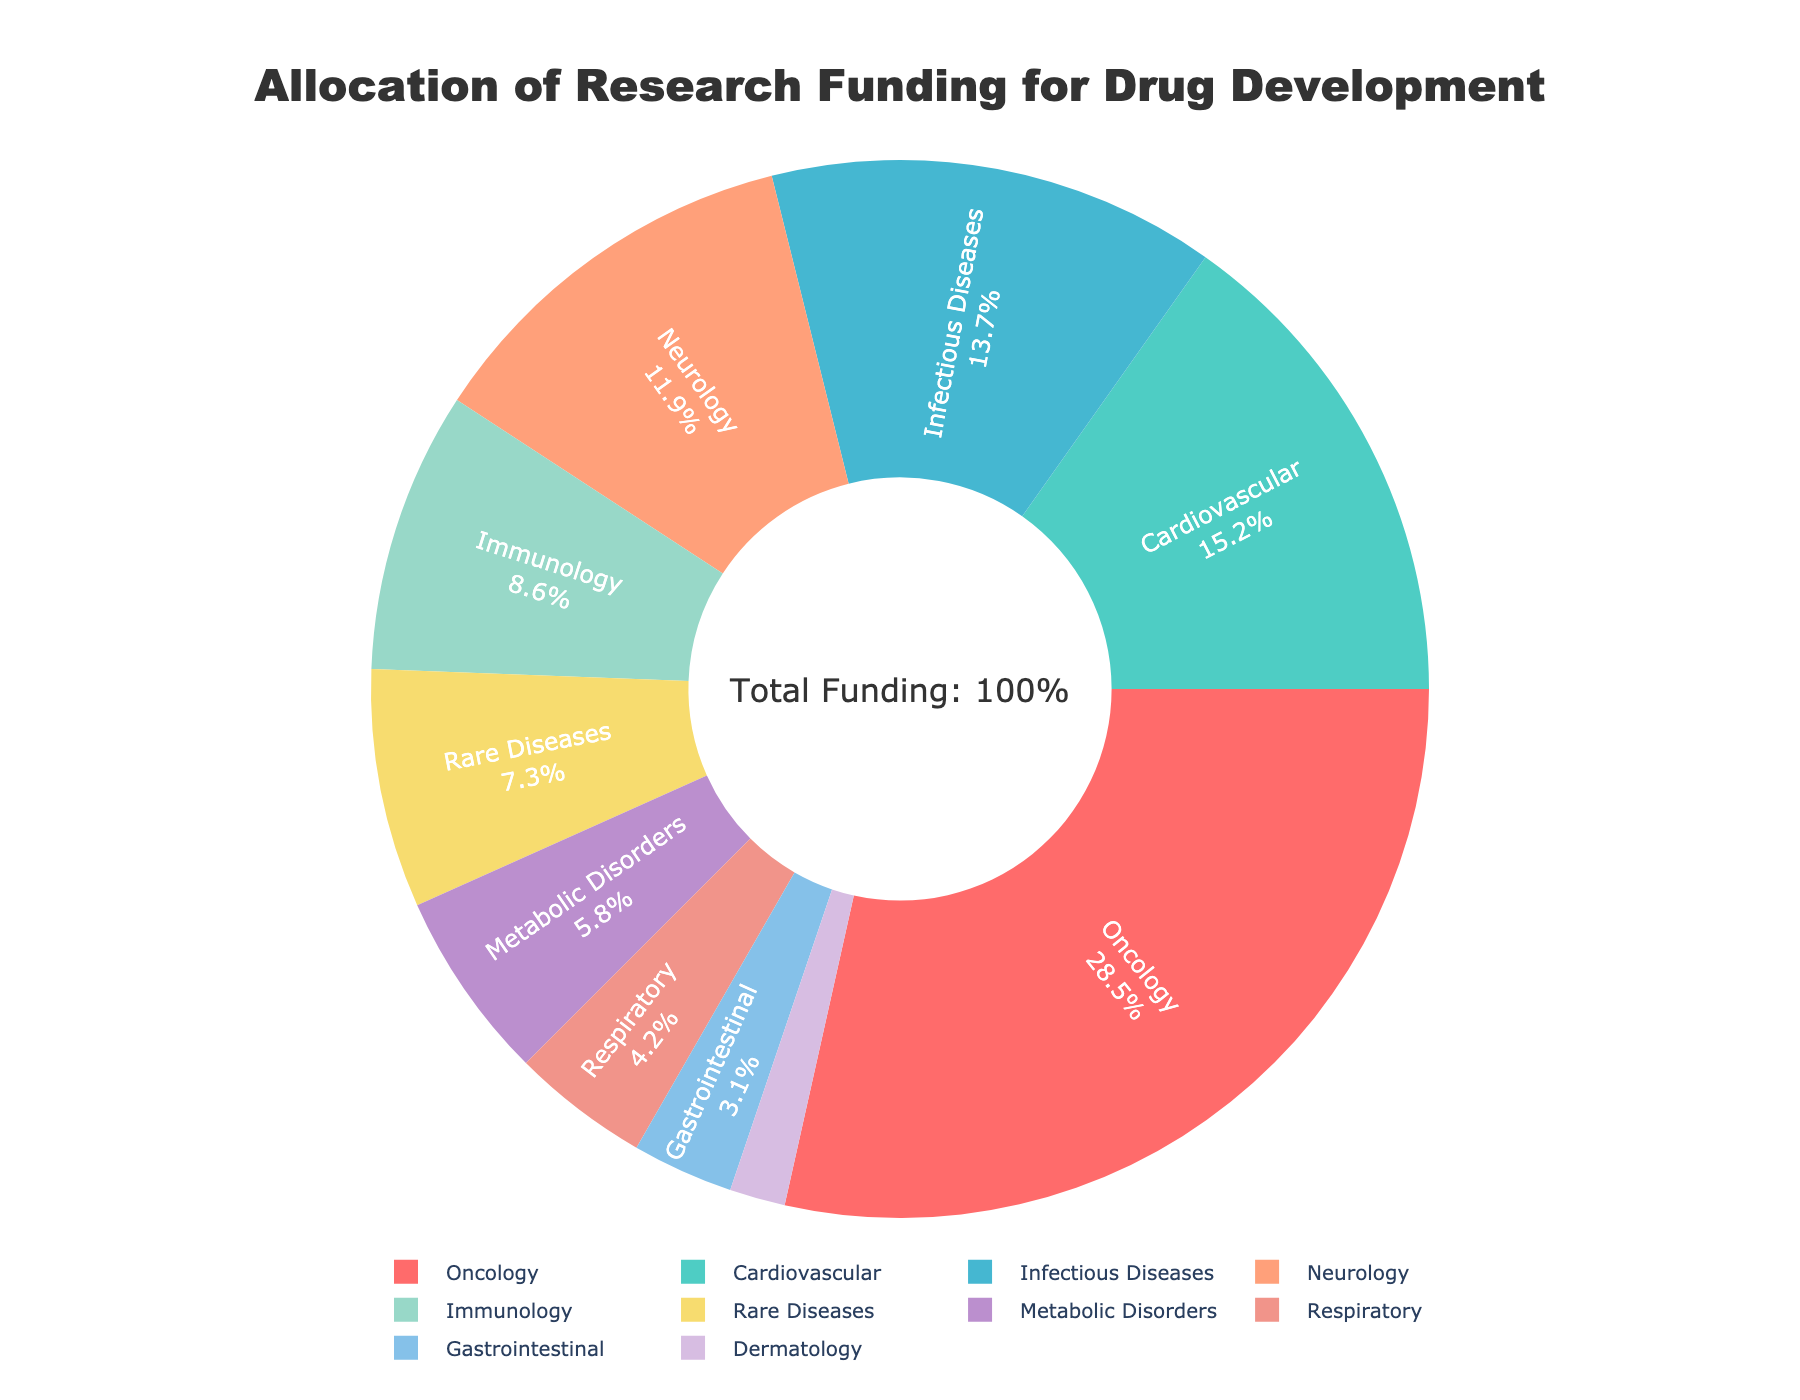what proportion of the research funding is allocated to Oncology? According to the pie chart, the funding percentage allocated to Oncology is clearly indicated.
Answer: 28.5% Which drug type received more funding: Neurology or Cardiovascular? By comparing the funding percentages for Neurology and Cardiovascular displayed in the pie chart, we can see that Cardiovascular received 15.2% whereas Neurology received 11.9%.
Answer: Cardiovascular Which drug type has the smallest funding allocation? The smallest segment in the pie chart represents Dermatology, which has the lowest percentage of funding.
Answer: Dermatology What is the combined funding percentage for Neurology and Immunology? To find the combined funding percentage, add the percentages of Neurology (11.9%) and Immunology (8.6%). Therefore, 11.9 + 8.6 = 20.5.
Answer: 20.5% Is the funding for Infectious Diseases greater than the combined funding for Metabolic Disorders and Respiratory? Compare the funding percentage for Infectious Diseases (13.7%) with the sum of Metabolic Disorders (5.8%) and Respiratory (4.2%). Thus, 5.8 + 4.2 = 10. This confirms that 13.7 > 10.
Answer: Yes What are the funding percentages for the top three drug types? The top three drug types by funding are Oncology, Cardiovascular, and Infectious Diseases. They correspond to 28.5%, 15.2%, and 13.7% respectively.
Answer: 28.5%, 15.2%, 13.7% How much more funding is allocated to Oncology compared to Rare Diseases? Subtract the funding for Rare Diseases (7.3%) from the funding for Oncology (28.5%). Therefore, 28.5 - 7.3 = 21.2.
Answer: 21.2% What is the average funding percentage of the bottom four drug types? The bottom four drug types are Dermatology, Gastrointestinal, Respiratory, and Metabolic Disorders. Their funding percentages are 1.7%, 3.1%, 4.2%, and 5.8%. The sum is 1.7 + 3.1 + 4.2 + 5.8 = 14.8%. Therefore, the average is 14.8 / 4 = 3.7%.
Answer: 3.7% Does the funding for Oncology exceed the total funding for Cardiovascular and Infectious Diseases combined? Add the funding for Cardiovascular (15.2%) and Infectious Diseases (13.7%). The total is 15.2 + 13.7 = 28.9%. Compare this to Oncology's 28.5%. Thus, 28.5 < 28.9.
Answer: No 